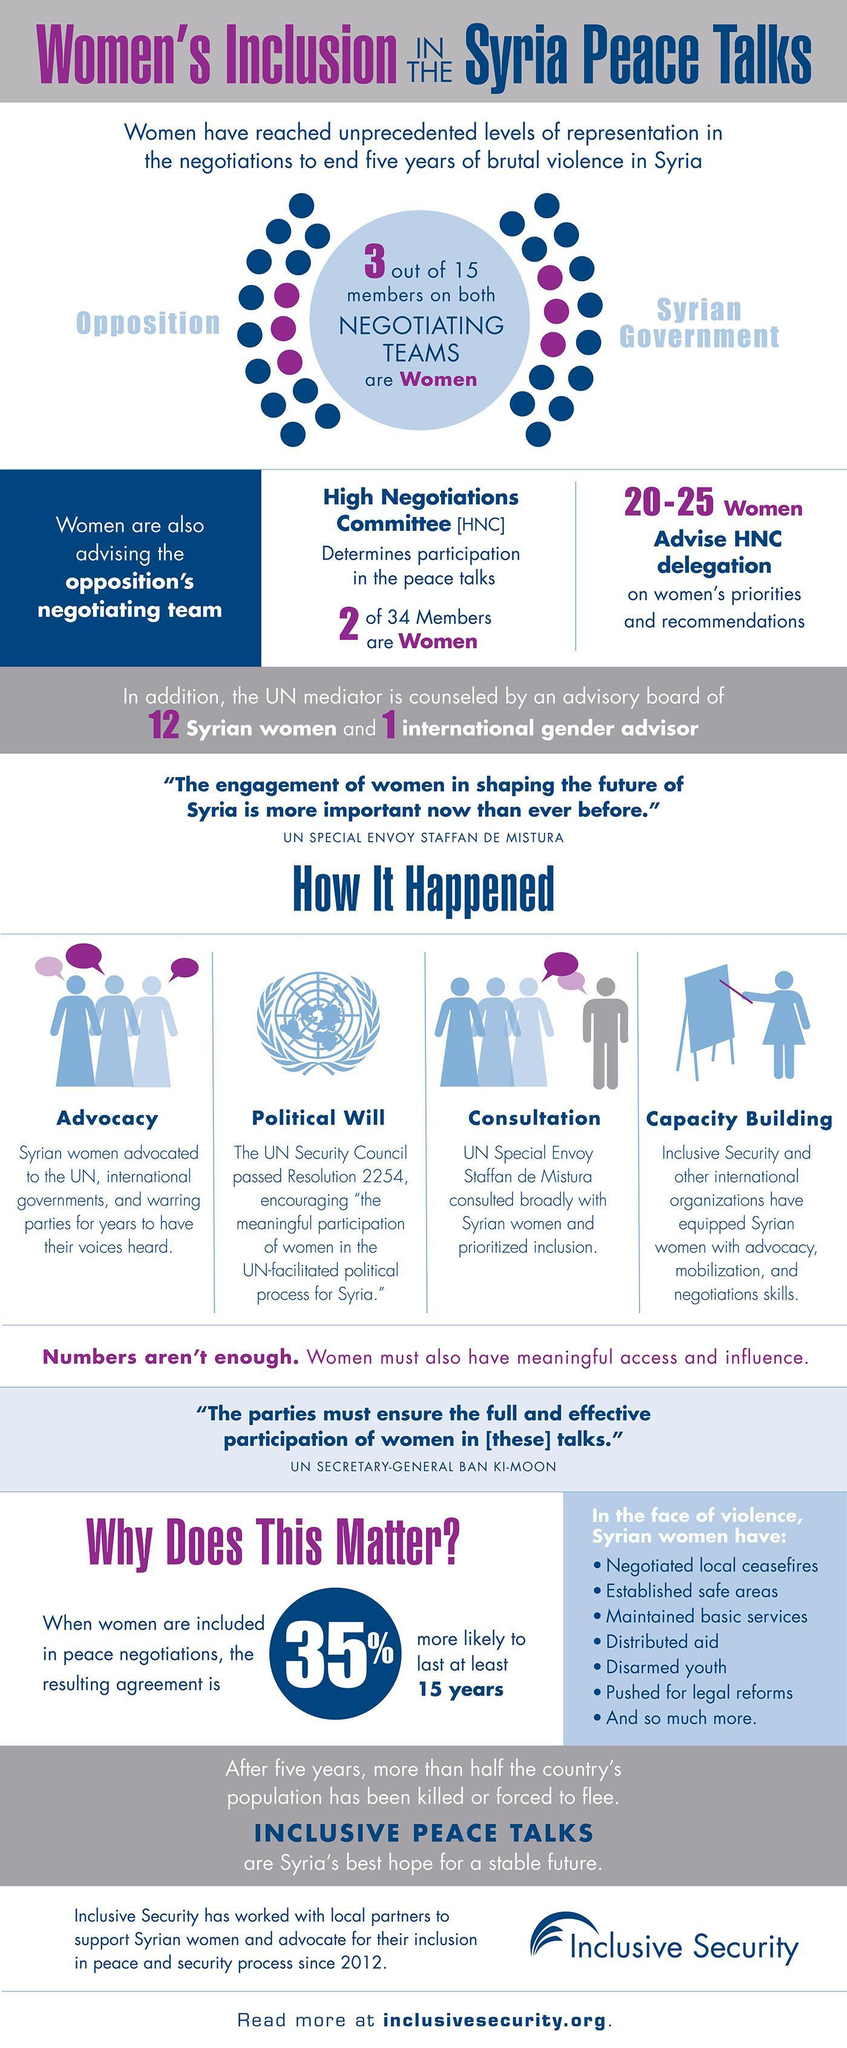How many of the total 30 members in the negotiating teams are women
Answer the question with a short phrase. 6 Which are the 2 teams who are negotiation in the syria peace talks Opposition, Syrian Government How many actions points have syrian women taken in the face of violence 7 What is the total number of women and international general advisor in the advisory board 13 